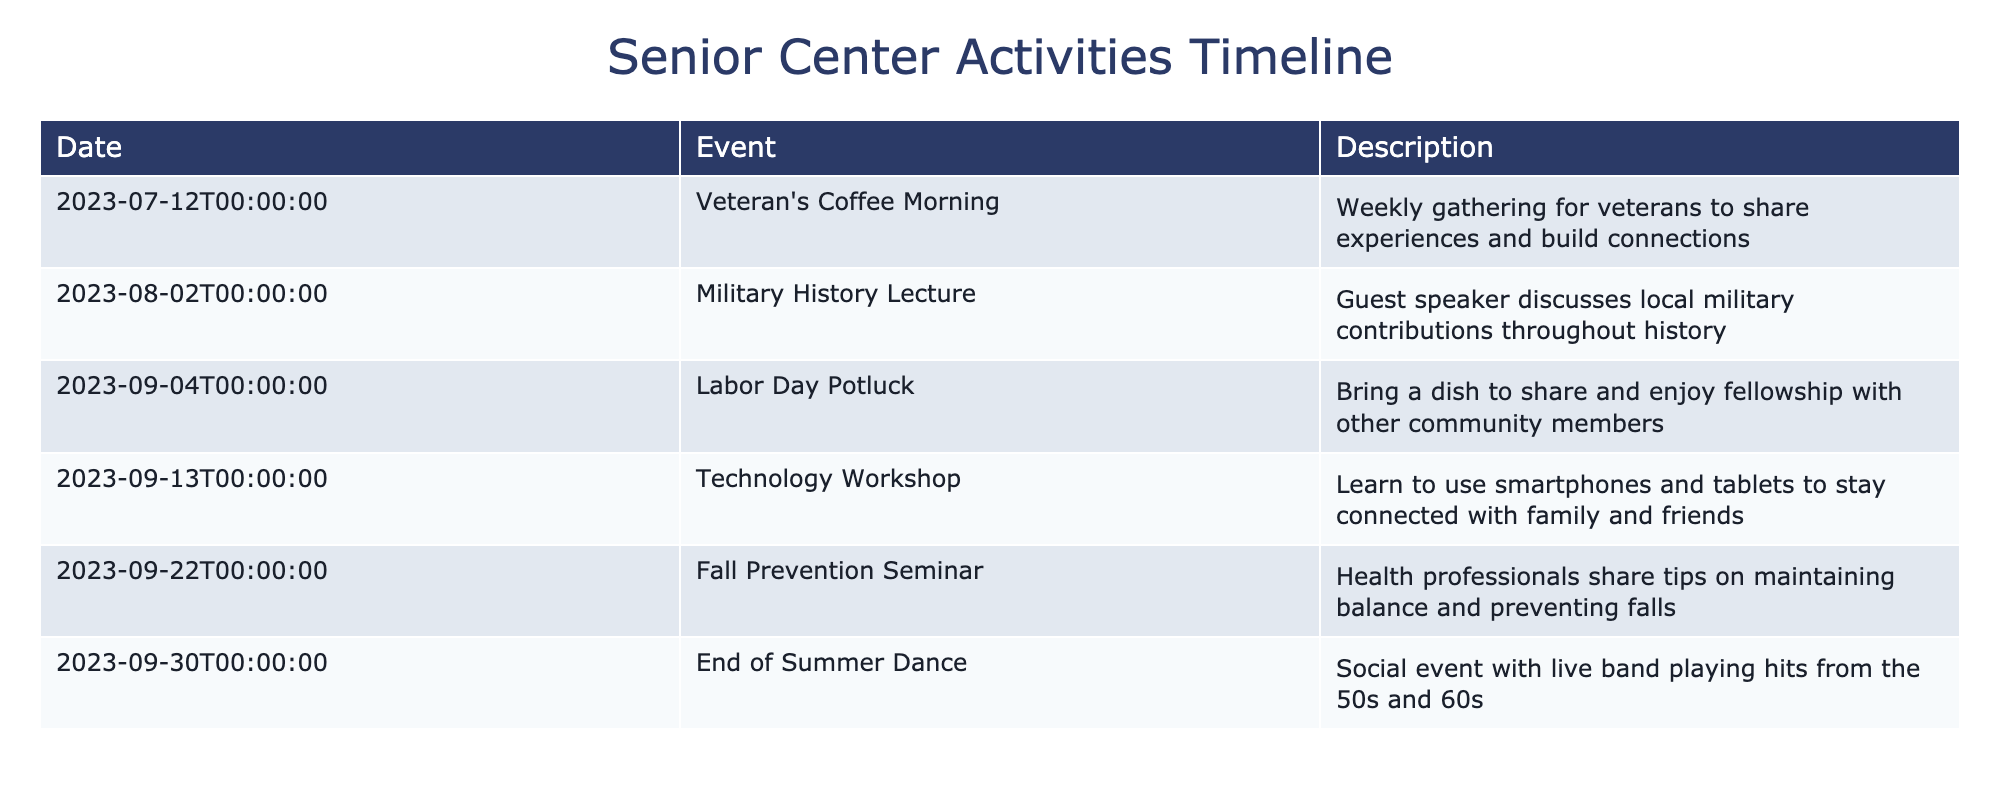What is the date of the Fall Prevention Seminar? The table displays the date and event details. Searching for "Fall Prevention Seminar" shows that it is scheduled for "2023-09-22."
Answer: 2023-09-22 How many events are scheduled in September? By reviewing the table, there are three events listed in September: "Labor Day Potluck" on September 4, "Technology Workshop" on September 13, and "Fall Prevention Seminar" on September 22, along with the "End of Summer Dance" on September 30. Counting these gives a total of four events.
Answer: 4 Is there a dance event scheduled for this quarter? The table shows an "End of Summer Dance" event on September 30. This confirms that there is indeed a dance event planned.
Answer: Yes What is the total number of events happening in July and August combined? The table provides information on events in July and August. In July, there is one event: "Veteran's Coffee Morning." In August, there is one event: "Military History Lecture." Adding both provides a total of two events for these months.
Answer: 2 Are any technology workshops offered in this quarter? The table lists the "Technology Workshop" on September 13, indicating that there is indeed a technology workshop being offered this quarter.
Answer: Yes Which event occurs closest to Labor Day? The "Labor Day Potluck" is on September 4, then looking at subsequent events, we see "Technology Workshop" on September 13. Therefore, the closest event to Labor Day is "Technology Workshop."
Answer: Technology Workshop What type of gathering is the Veteran's Coffee Morning? The description provided for the "Veteran's Coffee Morning" event states that it is a "Weekly gathering for veterans to share experiences and build connections." This indicates that the gathering focuses on social interaction among veterans.
Answer: Weekly gathering for veterans How many events focus on health and wellness in this quarter? In the provided table, there are two events related to health and wellness: "Fall Prevention Seminar" and "Technology Workshop," since technology also plays a role in staying connected which can impact mental health and wellness. Thus, the total number is counted as two.
Answer: 2 